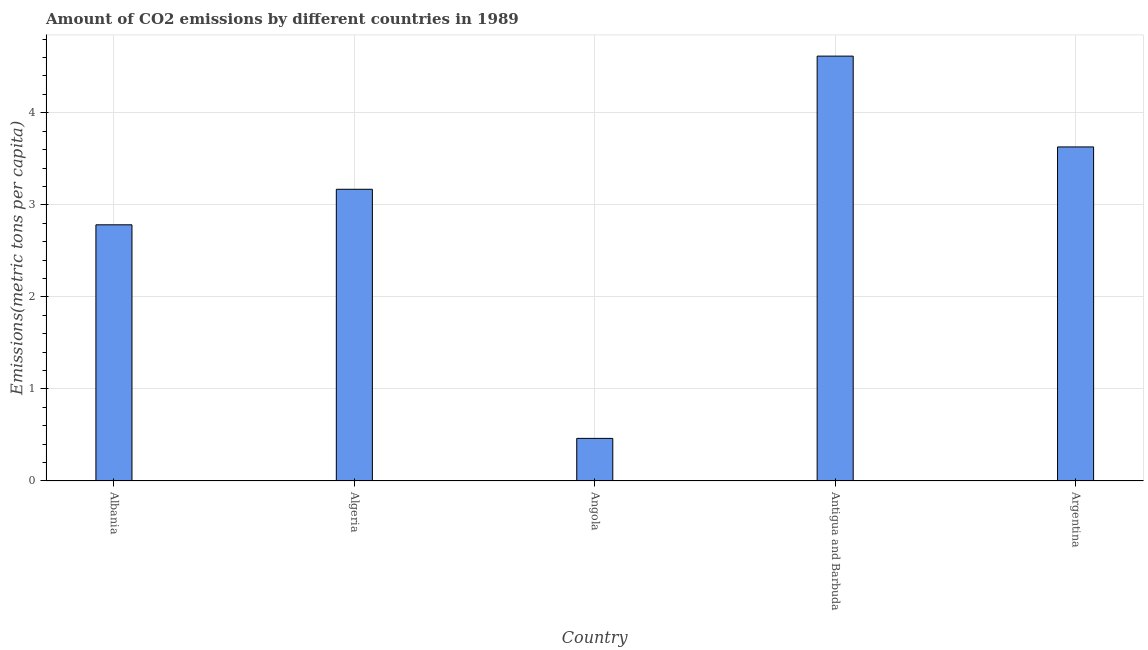Does the graph contain any zero values?
Give a very brief answer. No. What is the title of the graph?
Give a very brief answer. Amount of CO2 emissions by different countries in 1989. What is the label or title of the Y-axis?
Provide a short and direct response. Emissions(metric tons per capita). What is the amount of co2 emissions in Angola?
Offer a very short reply. 0.46. Across all countries, what is the maximum amount of co2 emissions?
Offer a terse response. 4.62. Across all countries, what is the minimum amount of co2 emissions?
Your response must be concise. 0.46. In which country was the amount of co2 emissions maximum?
Keep it short and to the point. Antigua and Barbuda. In which country was the amount of co2 emissions minimum?
Offer a very short reply. Angola. What is the sum of the amount of co2 emissions?
Your response must be concise. 14.66. What is the difference between the amount of co2 emissions in Algeria and Angola?
Your answer should be compact. 2.71. What is the average amount of co2 emissions per country?
Make the answer very short. 2.93. What is the median amount of co2 emissions?
Make the answer very short. 3.17. In how many countries, is the amount of co2 emissions greater than 1.6 metric tons per capita?
Your response must be concise. 4. What is the ratio of the amount of co2 emissions in Antigua and Barbuda to that in Argentina?
Your answer should be very brief. 1.27. Is the amount of co2 emissions in Algeria less than that in Angola?
Provide a succinct answer. No. Is the difference between the amount of co2 emissions in Albania and Antigua and Barbuda greater than the difference between any two countries?
Offer a terse response. No. Is the sum of the amount of co2 emissions in Algeria and Argentina greater than the maximum amount of co2 emissions across all countries?
Give a very brief answer. Yes. What is the difference between the highest and the lowest amount of co2 emissions?
Give a very brief answer. 4.15. In how many countries, is the amount of co2 emissions greater than the average amount of co2 emissions taken over all countries?
Provide a short and direct response. 3. How many bars are there?
Ensure brevity in your answer.  5. Are all the bars in the graph horizontal?
Provide a succinct answer. No. What is the difference between two consecutive major ticks on the Y-axis?
Ensure brevity in your answer.  1. What is the Emissions(metric tons per capita) of Albania?
Ensure brevity in your answer.  2.78. What is the Emissions(metric tons per capita) in Algeria?
Keep it short and to the point. 3.17. What is the Emissions(metric tons per capita) of Angola?
Offer a terse response. 0.46. What is the Emissions(metric tons per capita) of Antigua and Barbuda?
Give a very brief answer. 4.62. What is the Emissions(metric tons per capita) of Argentina?
Offer a terse response. 3.63. What is the difference between the Emissions(metric tons per capita) in Albania and Algeria?
Give a very brief answer. -0.39. What is the difference between the Emissions(metric tons per capita) in Albania and Angola?
Provide a short and direct response. 2.32. What is the difference between the Emissions(metric tons per capita) in Albania and Antigua and Barbuda?
Offer a very short reply. -1.83. What is the difference between the Emissions(metric tons per capita) in Albania and Argentina?
Make the answer very short. -0.85. What is the difference between the Emissions(metric tons per capita) in Algeria and Angola?
Offer a very short reply. 2.71. What is the difference between the Emissions(metric tons per capita) in Algeria and Antigua and Barbuda?
Offer a very short reply. -1.45. What is the difference between the Emissions(metric tons per capita) in Algeria and Argentina?
Your answer should be compact. -0.46. What is the difference between the Emissions(metric tons per capita) in Angola and Antigua and Barbuda?
Your answer should be very brief. -4.15. What is the difference between the Emissions(metric tons per capita) in Angola and Argentina?
Make the answer very short. -3.17. What is the difference between the Emissions(metric tons per capita) in Antigua and Barbuda and Argentina?
Provide a short and direct response. 0.99. What is the ratio of the Emissions(metric tons per capita) in Albania to that in Algeria?
Keep it short and to the point. 0.88. What is the ratio of the Emissions(metric tons per capita) in Albania to that in Angola?
Ensure brevity in your answer.  6.01. What is the ratio of the Emissions(metric tons per capita) in Albania to that in Antigua and Barbuda?
Make the answer very short. 0.6. What is the ratio of the Emissions(metric tons per capita) in Albania to that in Argentina?
Your response must be concise. 0.77. What is the ratio of the Emissions(metric tons per capita) in Algeria to that in Angola?
Ensure brevity in your answer.  6.85. What is the ratio of the Emissions(metric tons per capita) in Algeria to that in Antigua and Barbuda?
Keep it short and to the point. 0.69. What is the ratio of the Emissions(metric tons per capita) in Algeria to that in Argentina?
Offer a very short reply. 0.87. What is the ratio of the Emissions(metric tons per capita) in Angola to that in Antigua and Barbuda?
Your response must be concise. 0.1. What is the ratio of the Emissions(metric tons per capita) in Angola to that in Argentina?
Offer a very short reply. 0.13. What is the ratio of the Emissions(metric tons per capita) in Antigua and Barbuda to that in Argentina?
Your response must be concise. 1.27. 